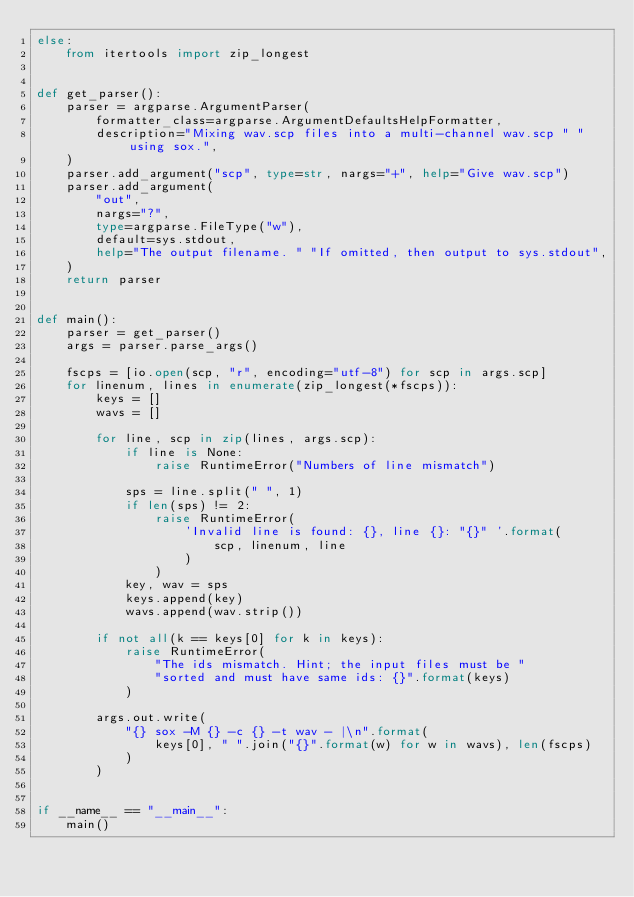<code> <loc_0><loc_0><loc_500><loc_500><_Python_>else:
    from itertools import zip_longest


def get_parser():
    parser = argparse.ArgumentParser(
        formatter_class=argparse.ArgumentDefaultsHelpFormatter,
        description="Mixing wav.scp files into a multi-channel wav.scp " "using sox.",
    )
    parser.add_argument("scp", type=str, nargs="+", help="Give wav.scp")
    parser.add_argument(
        "out",
        nargs="?",
        type=argparse.FileType("w"),
        default=sys.stdout,
        help="The output filename. " "If omitted, then output to sys.stdout",
    )
    return parser


def main():
    parser = get_parser()
    args = parser.parse_args()

    fscps = [io.open(scp, "r", encoding="utf-8") for scp in args.scp]
    for linenum, lines in enumerate(zip_longest(*fscps)):
        keys = []
        wavs = []

        for line, scp in zip(lines, args.scp):
            if line is None:
                raise RuntimeError("Numbers of line mismatch")

            sps = line.split(" ", 1)
            if len(sps) != 2:
                raise RuntimeError(
                    'Invalid line is found: {}, line {}: "{}" '.format(
                        scp, linenum, line
                    )
                )
            key, wav = sps
            keys.append(key)
            wavs.append(wav.strip())

        if not all(k == keys[0] for k in keys):
            raise RuntimeError(
                "The ids mismatch. Hint; the input files must be "
                "sorted and must have same ids: {}".format(keys)
            )

        args.out.write(
            "{} sox -M {} -c {} -t wav - |\n".format(
                keys[0], " ".join("{}".format(w) for w in wavs), len(fscps)
            )
        )


if __name__ == "__main__":
    main()
</code> 